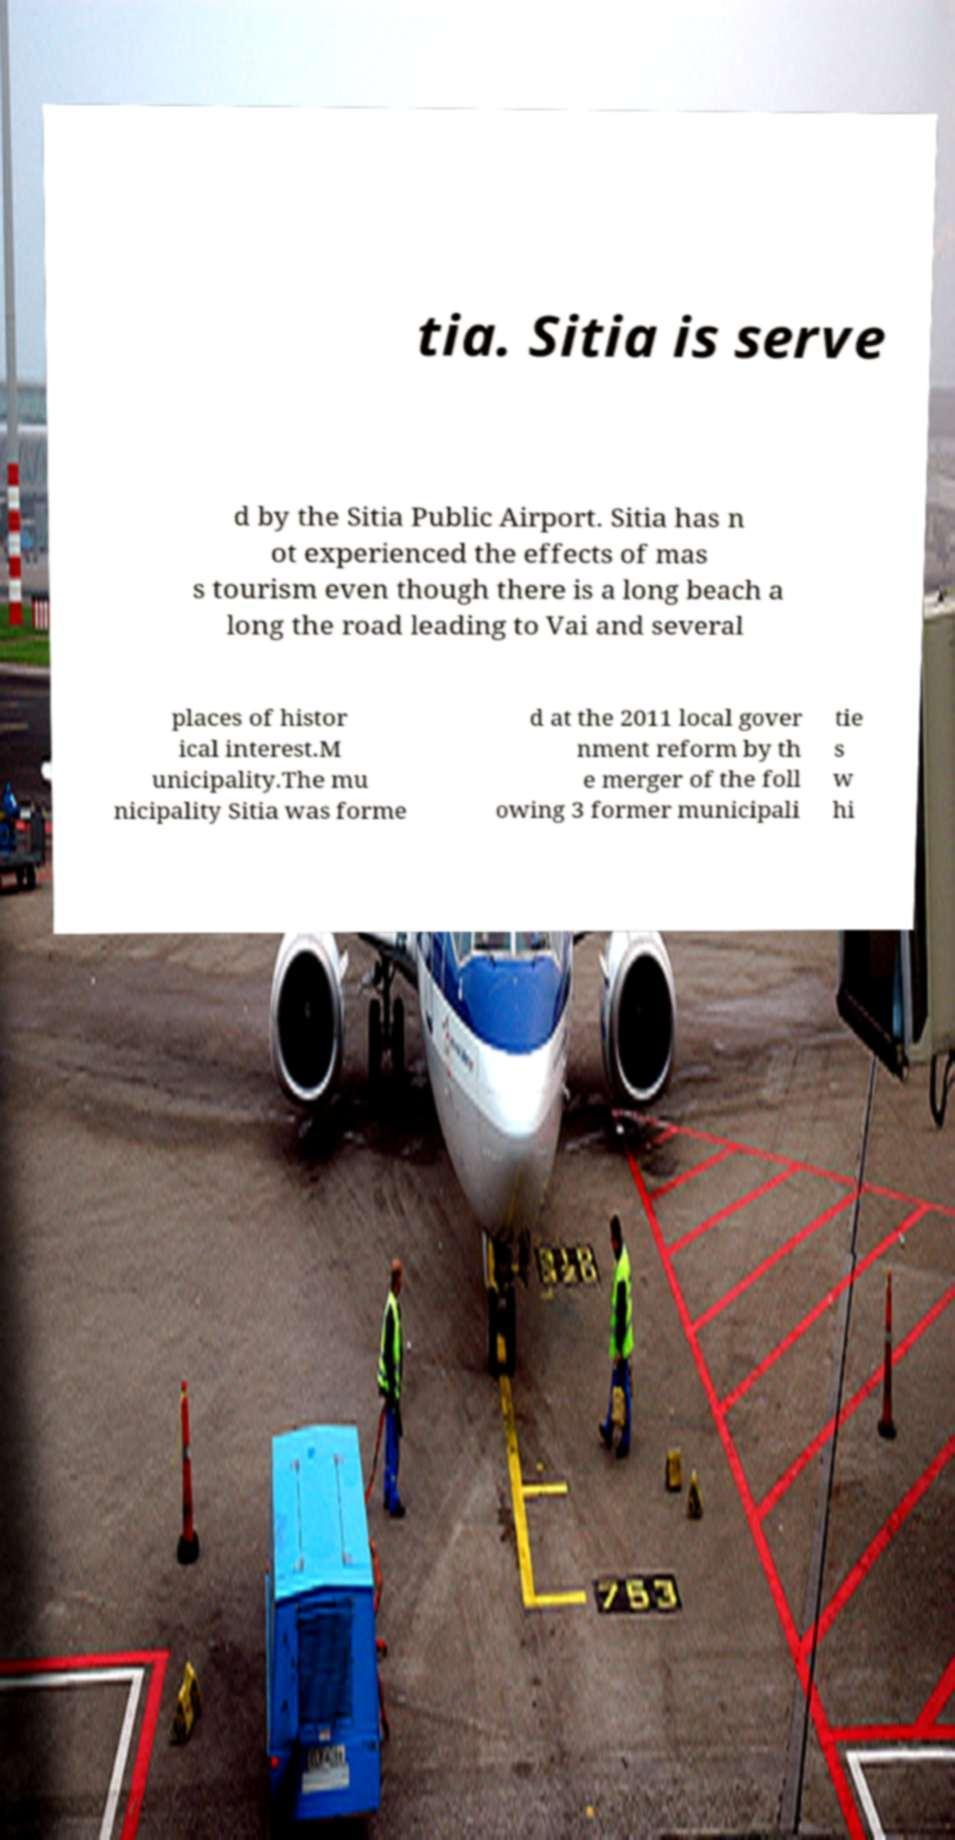Please read and relay the text visible in this image. What does it say? tia. Sitia is serve d by the Sitia Public Airport. Sitia has n ot experienced the effects of mas s tourism even though there is a long beach a long the road leading to Vai and several places of histor ical interest.M unicipality.The mu nicipality Sitia was forme d at the 2011 local gover nment reform by th e merger of the foll owing 3 former municipali tie s w hi 